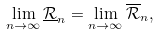<formula> <loc_0><loc_0><loc_500><loc_500>\lim _ { n \to \infty } \underline { \mathcal { R } } _ { n } = \lim _ { n \to \infty } \overline { \mathcal { R } } _ { n } ,</formula> 